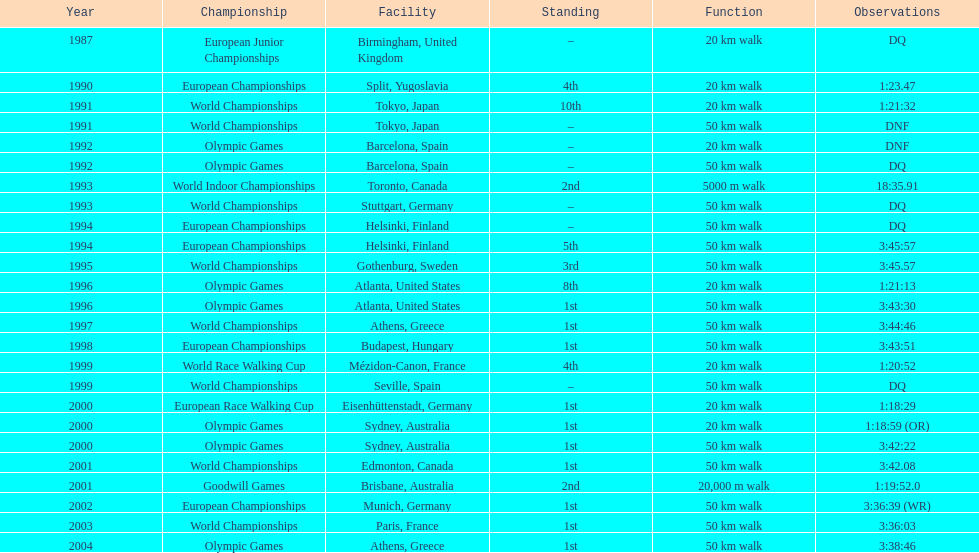Which venue is listed the most? Athens, Greece. 